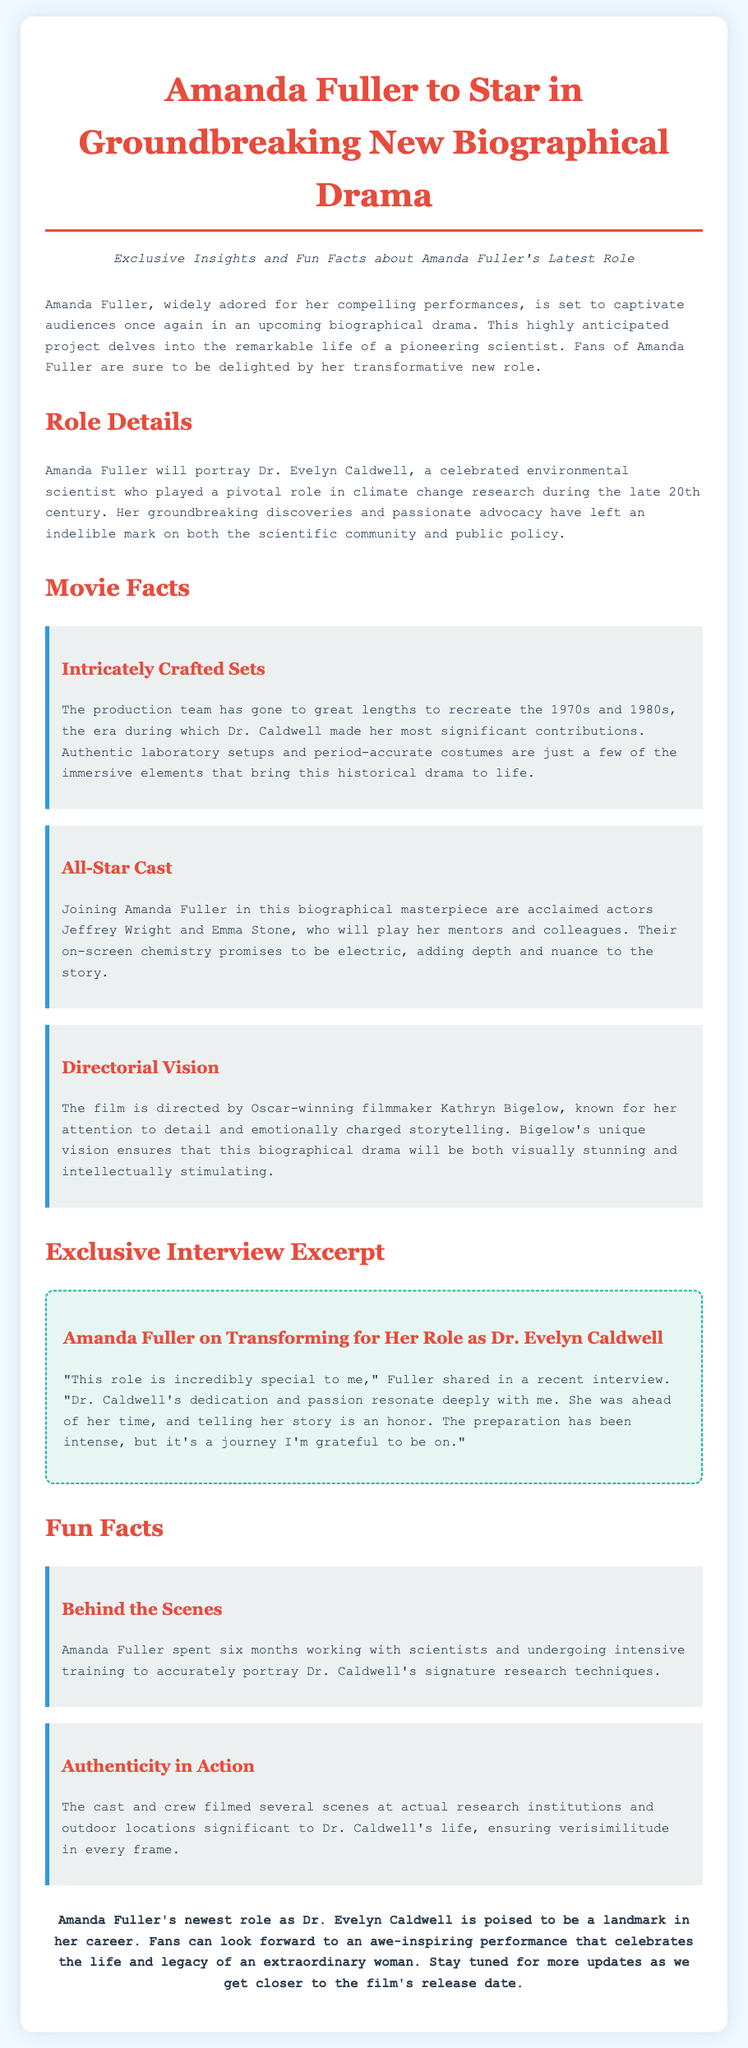What role will Amanda Fuller portray? The document states that Amanda Fuller will portray Dr. Evelyn Caldwell in the upcoming biographical drama.
Answer: Dr. Evelyn Caldwell What is the profession of the character Amanda Fuller is playing? The document describes Dr. Evelyn Caldwell as a celebrated environmental scientist.
Answer: Environmental scientist Who directed the film? The press release mentions that the film is directed by Oscar-winning filmmaker Kathryn Bigelow.
Answer: Kathryn Bigelow Which actors are mentioned as part of the cast? The document lists Jeffrey Wright and Emma Stone as co-stars alongside Amanda Fuller.
Answer: Jeffrey Wright and Emma Stone How long did Amanda Fuller train for her role? According to the document, Amanda Fuller spent six months working with scientists and undergoing training.
Answer: Six months What is a unique feature of the film's production? The document highlights that the production team recreated the 1970s and 1980s era with authentic setups.
Answer: Authentic laboratory setups What is Amanda Fuller's sentiment regarding her role? The interview excerpt showcases that Amanda Fuller feels the role is incredibly special to her.
Answer: Incredibly special What is the aim of the biographical drama? The document indicates that the aim is to celebrate the life and legacy of an extraordinary woman.
Answer: Celebrate the life and legacy of an extraordinary woman 